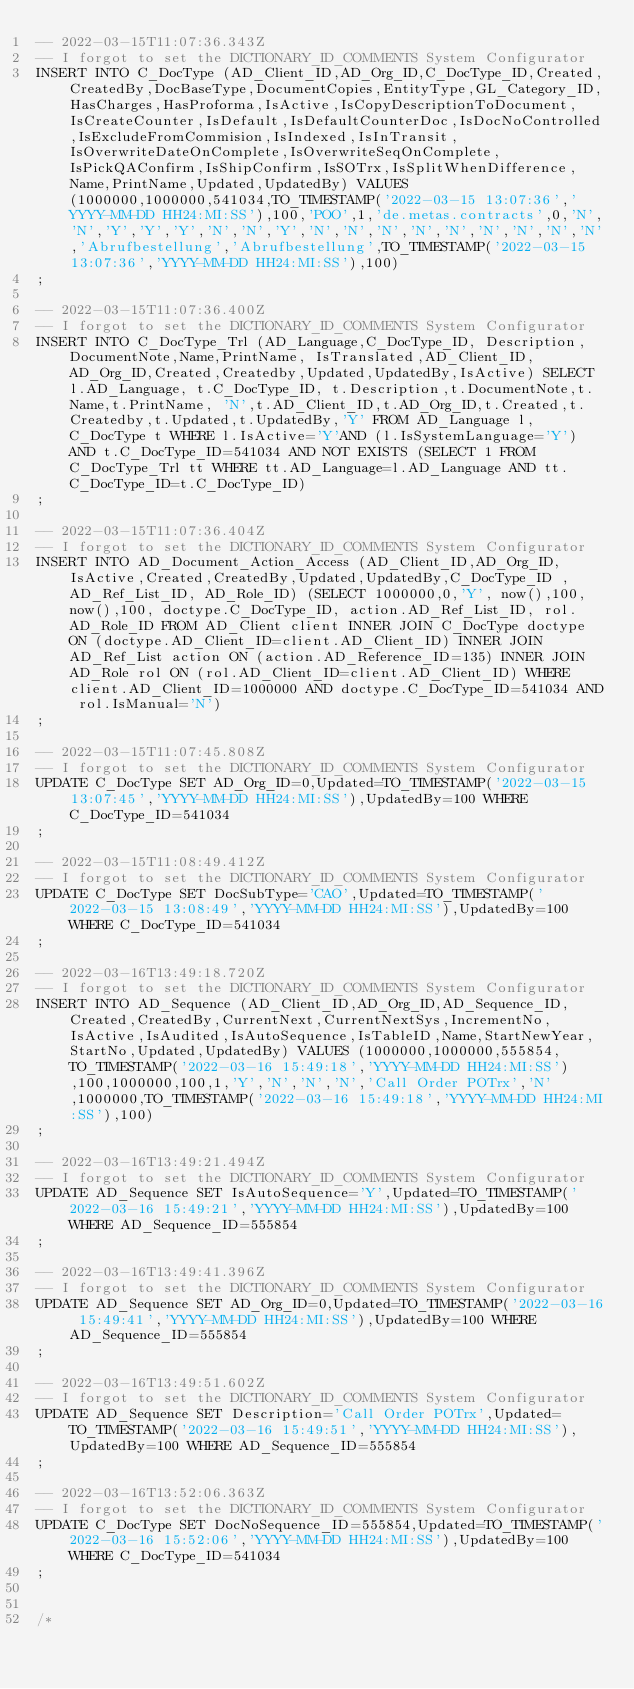Convert code to text. <code><loc_0><loc_0><loc_500><loc_500><_SQL_>-- 2022-03-15T11:07:36.343Z
-- I forgot to set the DICTIONARY_ID_COMMENTS System Configurator
INSERT INTO C_DocType (AD_Client_ID,AD_Org_ID,C_DocType_ID,Created,CreatedBy,DocBaseType,DocumentCopies,EntityType,GL_Category_ID,HasCharges,HasProforma,IsActive,IsCopyDescriptionToDocument,IsCreateCounter,IsDefault,IsDefaultCounterDoc,IsDocNoControlled,IsExcludeFromCommision,IsIndexed,IsInTransit,IsOverwriteDateOnComplete,IsOverwriteSeqOnComplete,IsPickQAConfirm,IsShipConfirm,IsSOTrx,IsSplitWhenDifference,Name,PrintName,Updated,UpdatedBy) VALUES (1000000,1000000,541034,TO_TIMESTAMP('2022-03-15 13:07:36','YYYY-MM-DD HH24:MI:SS'),100,'POO',1,'de.metas.contracts',0,'N','N','Y','Y','Y','N','N','Y','N','N','N','N','N','N','N','N','N','Abrufbestellung','Abrufbestellung',TO_TIMESTAMP('2022-03-15 13:07:36','YYYY-MM-DD HH24:MI:SS'),100)
;

-- 2022-03-15T11:07:36.400Z
-- I forgot to set the DICTIONARY_ID_COMMENTS System Configurator
INSERT INTO C_DocType_Trl (AD_Language,C_DocType_ID, Description,DocumentNote,Name,PrintName, IsTranslated,AD_Client_ID,AD_Org_ID,Created,Createdby,Updated,UpdatedBy,IsActive) SELECT l.AD_Language, t.C_DocType_ID, t.Description,t.DocumentNote,t.Name,t.PrintName, 'N',t.AD_Client_ID,t.AD_Org_ID,t.Created,t.Createdby,t.Updated,t.UpdatedBy,'Y' FROM AD_Language l, C_DocType t WHERE l.IsActive='Y'AND (l.IsSystemLanguage='Y') AND t.C_DocType_ID=541034 AND NOT EXISTS (SELECT 1 FROM C_DocType_Trl tt WHERE tt.AD_Language=l.AD_Language AND tt.C_DocType_ID=t.C_DocType_ID)
;

-- 2022-03-15T11:07:36.404Z
-- I forgot to set the DICTIONARY_ID_COMMENTS System Configurator
INSERT INTO AD_Document_Action_Access (AD_Client_ID,AD_Org_ID,IsActive,Created,CreatedBy,Updated,UpdatedBy,C_DocType_ID , AD_Ref_List_ID, AD_Role_ID) (SELECT 1000000,0,'Y', now(),100, now(),100, doctype.C_DocType_ID, action.AD_Ref_List_ID, rol.AD_Role_ID FROM AD_Client client INNER JOIN C_DocType doctype ON (doctype.AD_Client_ID=client.AD_Client_ID) INNER JOIN AD_Ref_List action ON (action.AD_Reference_ID=135) INNER JOIN AD_Role rol ON (rol.AD_Client_ID=client.AD_Client_ID) WHERE client.AD_Client_ID=1000000 AND doctype.C_DocType_ID=541034 AND rol.IsManual='N')
;

-- 2022-03-15T11:07:45.808Z
-- I forgot to set the DICTIONARY_ID_COMMENTS System Configurator
UPDATE C_DocType SET AD_Org_ID=0,Updated=TO_TIMESTAMP('2022-03-15 13:07:45','YYYY-MM-DD HH24:MI:SS'),UpdatedBy=100 WHERE C_DocType_ID=541034
;

-- 2022-03-15T11:08:49.412Z
-- I forgot to set the DICTIONARY_ID_COMMENTS System Configurator
UPDATE C_DocType SET DocSubType='CAO',Updated=TO_TIMESTAMP('2022-03-15 13:08:49','YYYY-MM-DD HH24:MI:SS'),UpdatedBy=100 WHERE C_DocType_ID=541034
;

-- 2022-03-16T13:49:18.720Z
-- I forgot to set the DICTIONARY_ID_COMMENTS System Configurator
INSERT INTO AD_Sequence (AD_Client_ID,AD_Org_ID,AD_Sequence_ID,Created,CreatedBy,CurrentNext,CurrentNextSys,IncrementNo,IsActive,IsAudited,IsAutoSequence,IsTableID,Name,StartNewYear,StartNo,Updated,UpdatedBy) VALUES (1000000,1000000,555854,TO_TIMESTAMP('2022-03-16 15:49:18','YYYY-MM-DD HH24:MI:SS'),100,1000000,100,1,'Y','N','N','N','Call Order POTrx','N',1000000,TO_TIMESTAMP('2022-03-16 15:49:18','YYYY-MM-DD HH24:MI:SS'),100)
;

-- 2022-03-16T13:49:21.494Z
-- I forgot to set the DICTIONARY_ID_COMMENTS System Configurator
UPDATE AD_Sequence SET IsAutoSequence='Y',Updated=TO_TIMESTAMP('2022-03-16 15:49:21','YYYY-MM-DD HH24:MI:SS'),UpdatedBy=100 WHERE AD_Sequence_ID=555854
;

-- 2022-03-16T13:49:41.396Z
-- I forgot to set the DICTIONARY_ID_COMMENTS System Configurator
UPDATE AD_Sequence SET AD_Org_ID=0,Updated=TO_TIMESTAMP('2022-03-16 15:49:41','YYYY-MM-DD HH24:MI:SS'),UpdatedBy=100 WHERE AD_Sequence_ID=555854
;

-- 2022-03-16T13:49:51.602Z
-- I forgot to set the DICTIONARY_ID_COMMENTS System Configurator
UPDATE AD_Sequence SET Description='Call Order POTrx',Updated=TO_TIMESTAMP('2022-03-16 15:49:51','YYYY-MM-DD HH24:MI:SS'),UpdatedBy=100 WHERE AD_Sequence_ID=555854
;

-- 2022-03-16T13:52:06.363Z
-- I forgot to set the DICTIONARY_ID_COMMENTS System Configurator
UPDATE C_DocType SET DocNoSequence_ID=555854,Updated=TO_TIMESTAMP('2022-03-16 15:52:06','YYYY-MM-DD HH24:MI:SS'),UpdatedBy=100 WHERE C_DocType_ID=541034
;


/*</code> 